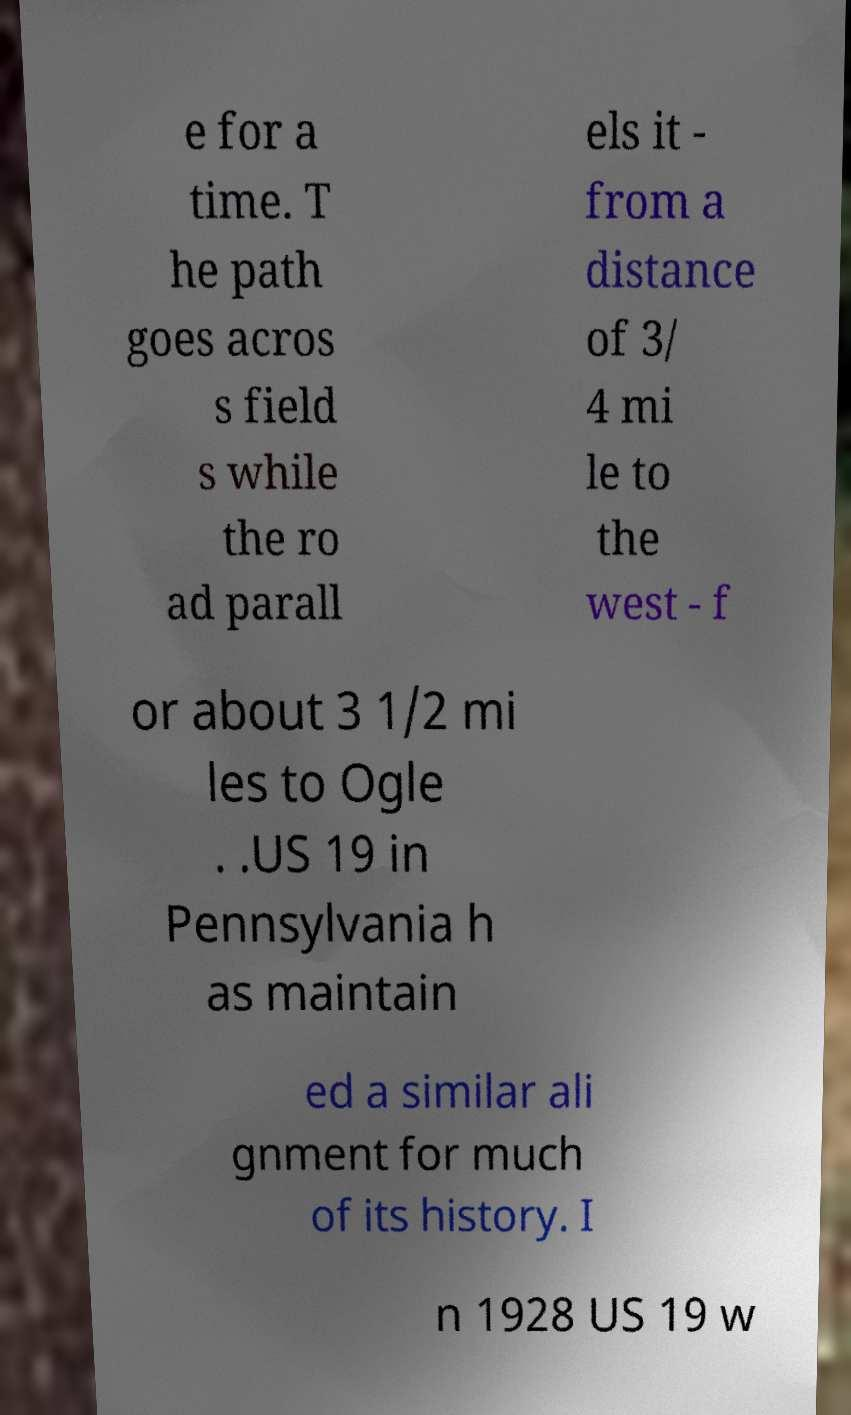For documentation purposes, I need the text within this image transcribed. Could you provide that? e for a time. T he path goes acros s field s while the ro ad parall els it - from a distance of 3/ 4 mi le to the west - f or about 3 1/2 mi les to Ogle . .US 19 in Pennsylvania h as maintain ed a similar ali gnment for much of its history. I n 1928 US 19 w 